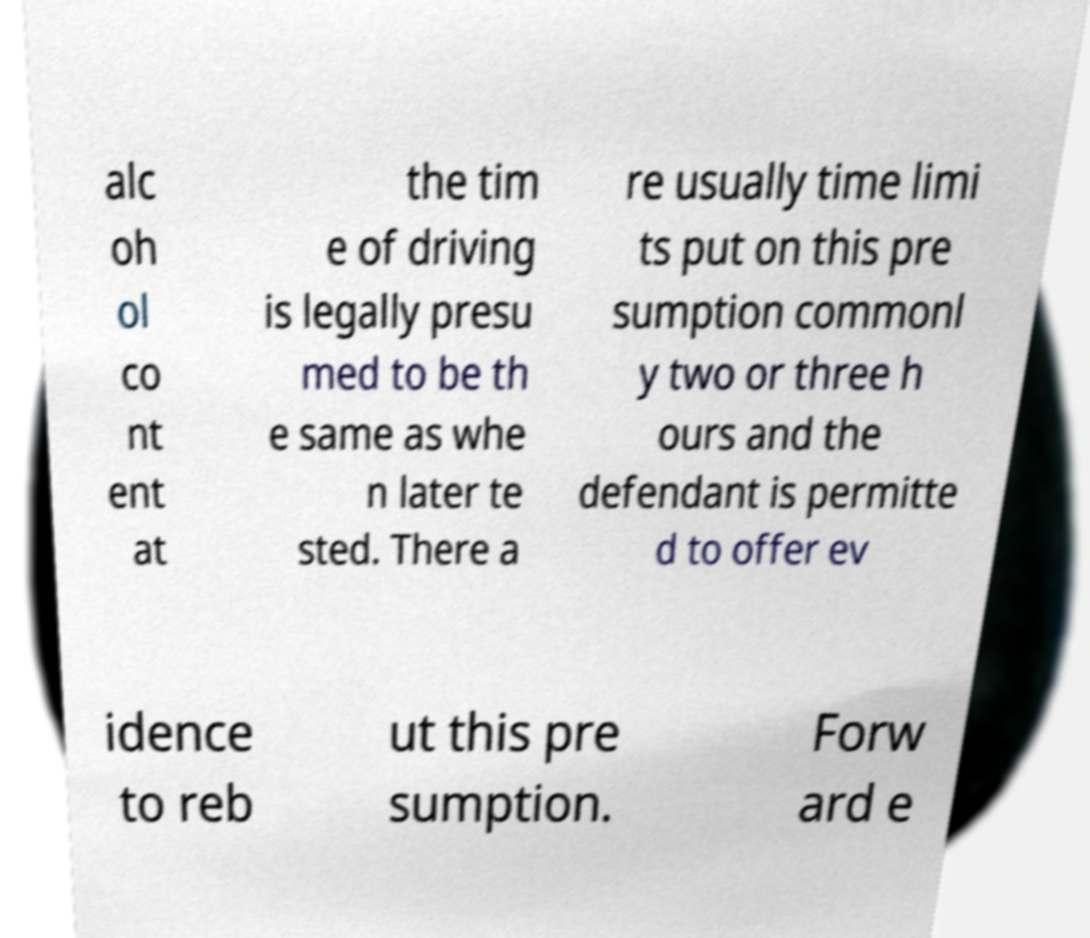Could you extract and type out the text from this image? alc oh ol co nt ent at the tim e of driving is legally presu med to be th e same as whe n later te sted. There a re usually time limi ts put on this pre sumption commonl y two or three h ours and the defendant is permitte d to offer ev idence to reb ut this pre sumption. Forw ard e 